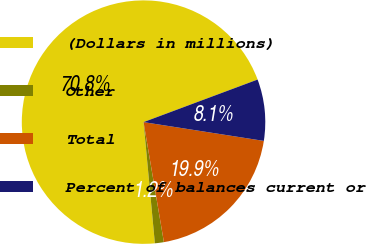Convert chart to OTSL. <chart><loc_0><loc_0><loc_500><loc_500><pie_chart><fcel>(Dollars in millions)<fcel>Other<fcel>Total<fcel>Percent of balances current or<nl><fcel>70.8%<fcel>1.19%<fcel>19.86%<fcel>8.15%<nl></chart> 